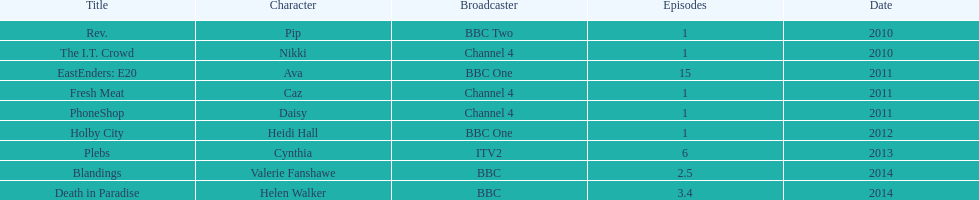In how many shows has sophie colguhoun made an appearance? 9. 